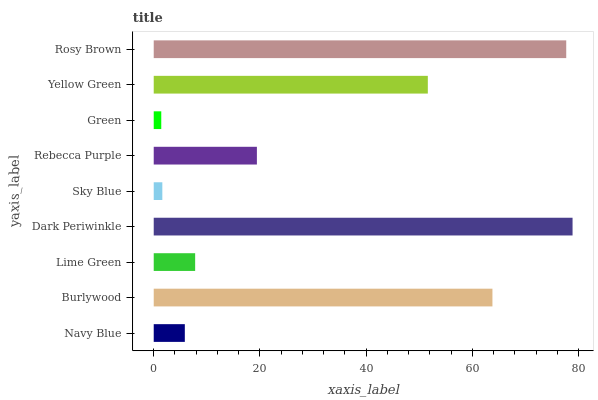Is Green the minimum?
Answer yes or no. Yes. Is Dark Periwinkle the maximum?
Answer yes or no. Yes. Is Burlywood the minimum?
Answer yes or no. No. Is Burlywood the maximum?
Answer yes or no. No. Is Burlywood greater than Navy Blue?
Answer yes or no. Yes. Is Navy Blue less than Burlywood?
Answer yes or no. Yes. Is Navy Blue greater than Burlywood?
Answer yes or no. No. Is Burlywood less than Navy Blue?
Answer yes or no. No. Is Rebecca Purple the high median?
Answer yes or no. Yes. Is Rebecca Purple the low median?
Answer yes or no. Yes. Is Green the high median?
Answer yes or no. No. Is Rosy Brown the low median?
Answer yes or no. No. 